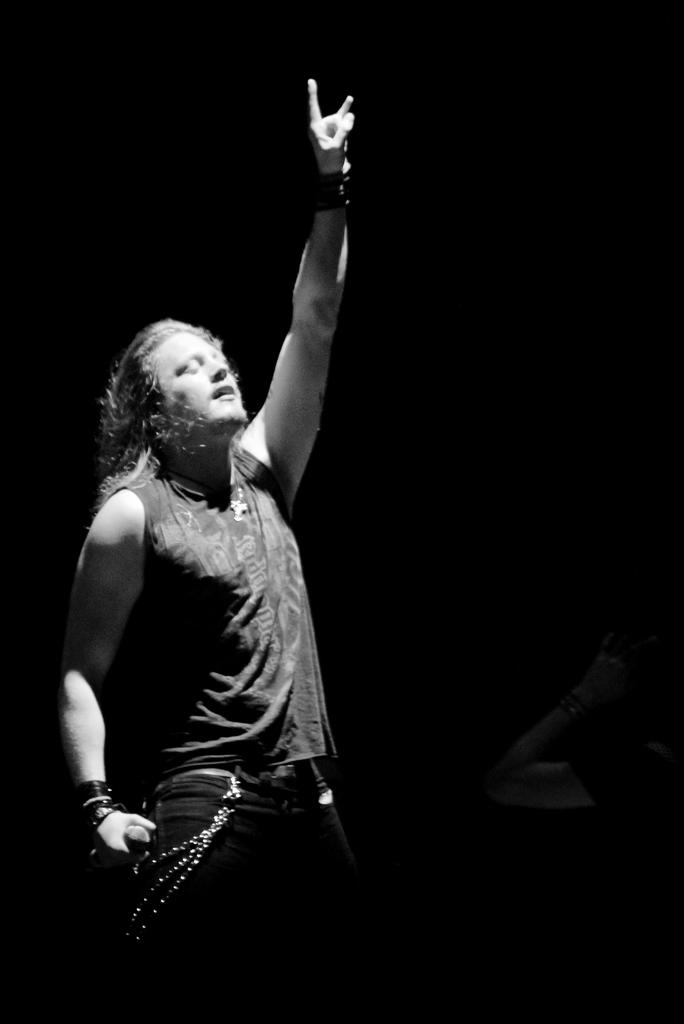Who is the main subject in the image? There is a man in the image. Where is the man located in the image? The man is on the left side of the image. What is the man wearing? The man is wearing a t-shirt and trousers. What is the man doing in the image? The man is singing. What can be observed about the background of the image? The background of the image is dark. What type of temper does the man have in the image? There is no information about the man's temper in the image. Is there any celery visible in the image? There is no celery present in the image. 